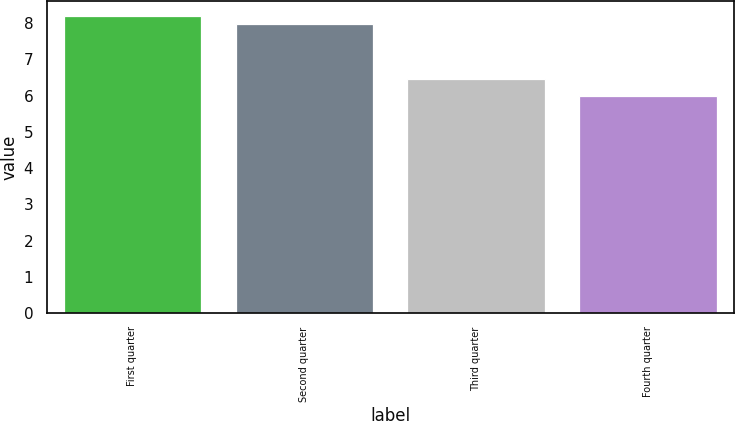<chart> <loc_0><loc_0><loc_500><loc_500><bar_chart><fcel>First quarter<fcel>Second quarter<fcel>Third quarter<fcel>Fourth quarter<nl><fcel>8.19<fcel>7.98<fcel>6.47<fcel>6<nl></chart> 